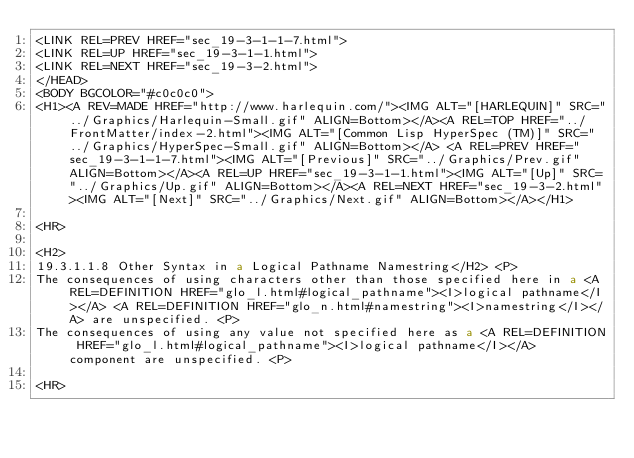<code> <loc_0><loc_0><loc_500><loc_500><_HTML_><LINK REL=PREV HREF="sec_19-3-1-1-7.html">
<LINK REL=UP HREF="sec_19-3-1-1.html">
<LINK REL=NEXT HREF="sec_19-3-2.html">
</HEAD>
<BODY BGCOLOR="#c0c0c0">
<H1><A REV=MADE HREF="http://www.harlequin.com/"><IMG ALT="[HARLEQUIN]" SRC="../Graphics/Harlequin-Small.gif" ALIGN=Bottom></A><A REL=TOP HREF="../FrontMatter/index-2.html"><IMG ALT="[Common Lisp HyperSpec (TM)]" SRC="../Graphics/HyperSpec-Small.gif" ALIGN=Bottom></A> <A REL=PREV HREF="sec_19-3-1-1-7.html"><IMG ALT="[Previous]" SRC="../Graphics/Prev.gif" ALIGN=Bottom></A><A REL=UP HREF="sec_19-3-1-1.html"><IMG ALT="[Up]" SRC="../Graphics/Up.gif" ALIGN=Bottom></A><A REL=NEXT HREF="sec_19-3-2.html"><IMG ALT="[Next]" SRC="../Graphics/Next.gif" ALIGN=Bottom></A></H1>

<HR>

<H2>
19.3.1.1.8 Other Syntax in a Logical Pathname Namestring</H2> <P>
The consequences of using characters other than those specified here in a <A REL=DEFINITION HREF="glo_l.html#logical_pathname"><I>logical pathname</I></A> <A REL=DEFINITION HREF="glo_n.html#namestring"><I>namestring</I></A> are unspecified. <P>
The consequences of using any value not specified here as a <A REL=DEFINITION HREF="glo_l.html#logical_pathname"><I>logical pathname</I></A> component are unspecified. <P>

<HR>
</code> 